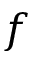<formula> <loc_0><loc_0><loc_500><loc_500>f</formula> 